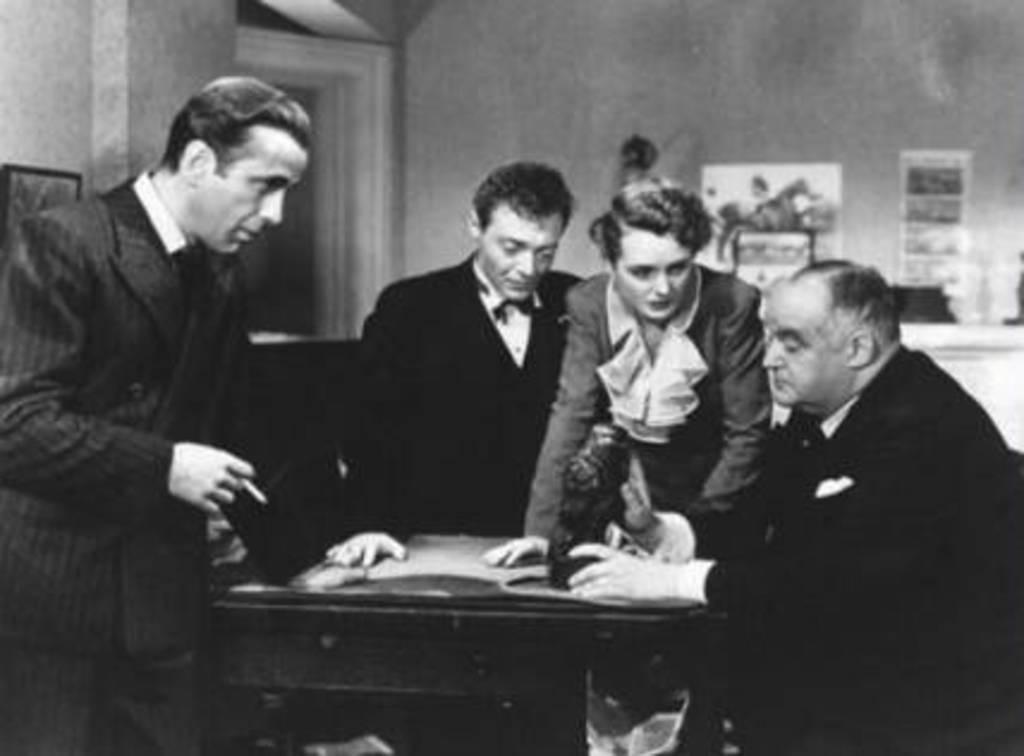How many people are present in the image? There are four people in the image. What are the positions of the people in the image? Some of the people are standing, while one is sitting. What is located between the people in the image? There is a table in between the people. What can be found on the table in the image? There is an item on the table. How many grapes are on the table in the image? There is no mention of grapes in the image, so we cannot determine their presence or quantity. 